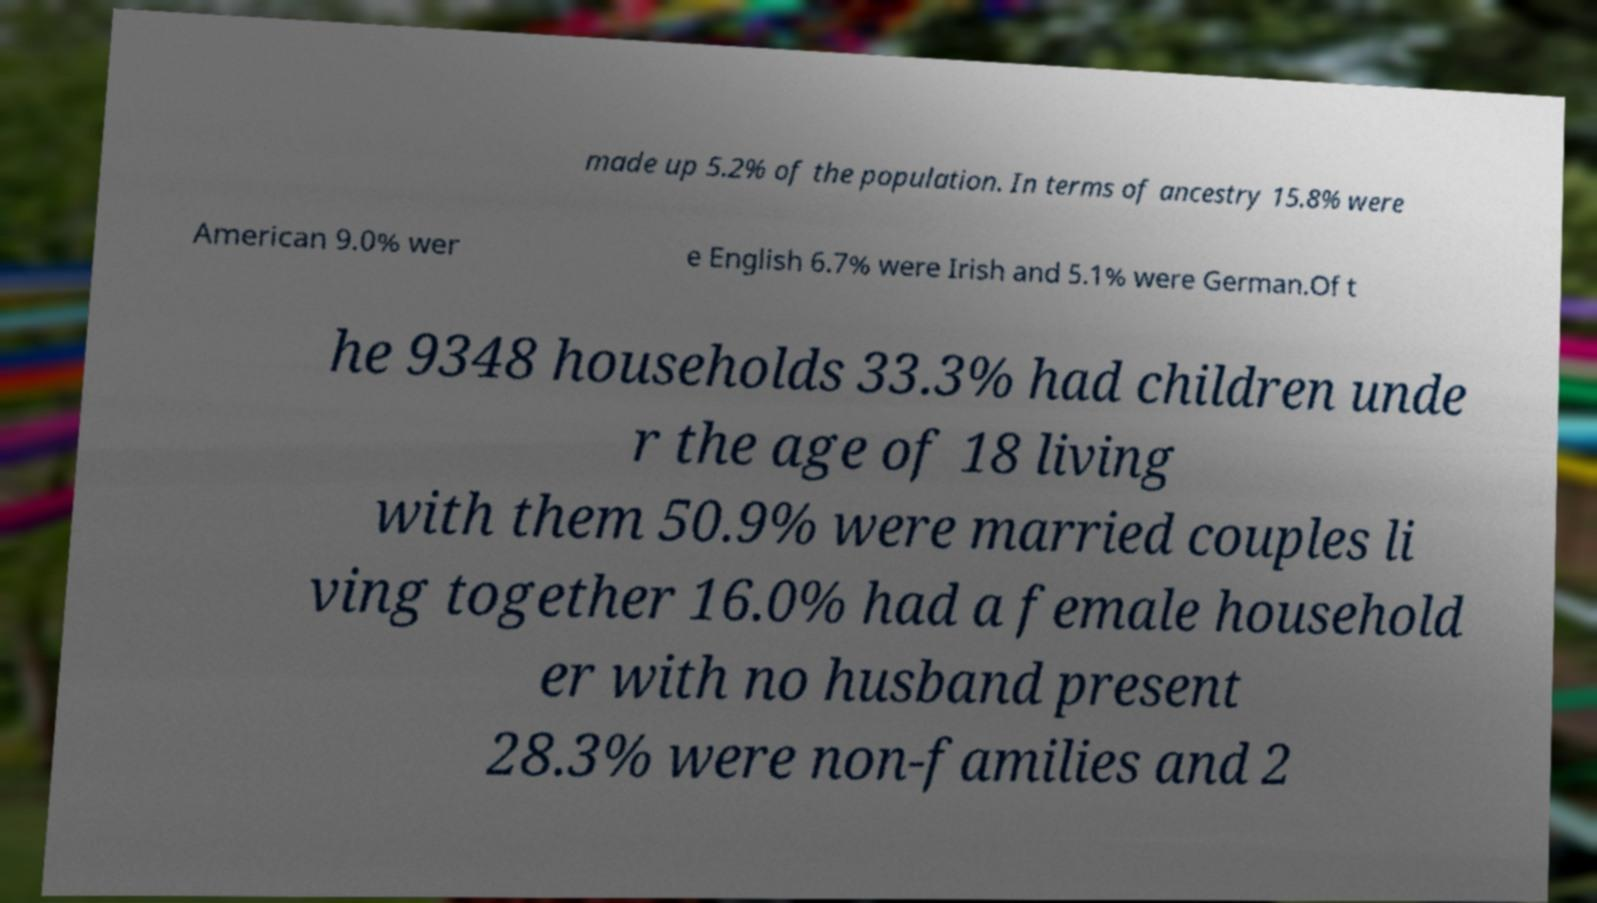Can you accurately transcribe the text from the provided image for me? made up 5.2% of the population. In terms of ancestry 15.8% were American 9.0% wer e English 6.7% were Irish and 5.1% were German.Of t he 9348 households 33.3% had children unde r the age of 18 living with them 50.9% were married couples li ving together 16.0% had a female household er with no husband present 28.3% were non-families and 2 